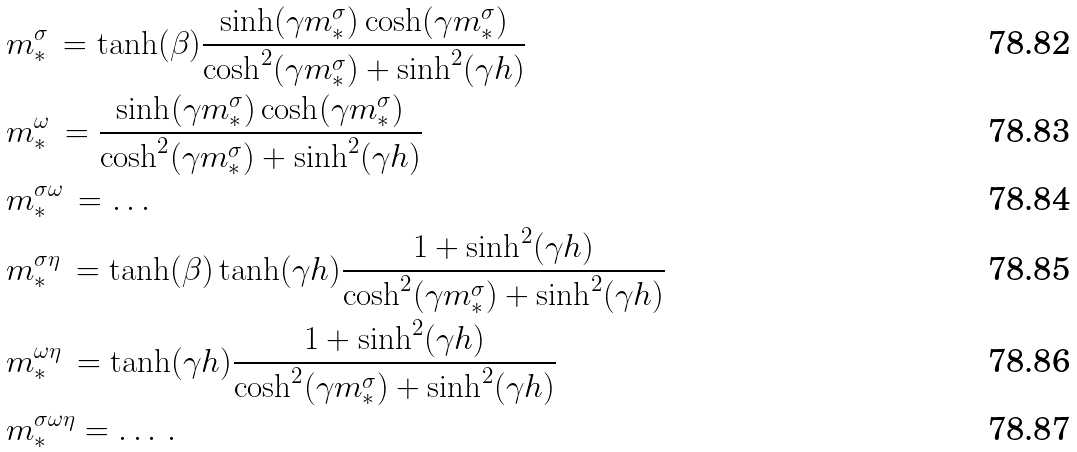<formula> <loc_0><loc_0><loc_500><loc_500>& m ^ { \sigma } _ { * } \, = \tanh ( \beta ) \frac { \sinh ( \gamma m ^ { \sigma } _ { * } ) \cosh ( \gamma m ^ { \sigma } _ { * } ) } { \cosh ^ { 2 } ( \gamma m ^ { \sigma } _ { * } ) + \sinh ^ { 2 } ( \gamma h ) } \\ & m ^ { \omega } _ { * } \, = \frac { \sinh ( \gamma m ^ { \sigma } _ { * } ) \cosh ( \gamma m ^ { \sigma } _ { * } ) } { \cosh ^ { 2 } ( \gamma m ^ { \sigma } _ { * } ) + \sinh ^ { 2 } ( \gamma h ) } \\ & m ^ { \sigma \omega } _ { * } \, = \dots \\ & m ^ { \sigma \eta } _ { * } \, = \tanh ( \beta ) \tanh ( \gamma h ) \frac { 1 + \sinh ^ { 2 } ( \gamma h ) } { \cosh ^ { 2 } ( \gamma m ^ { \sigma } _ { * } ) + \sinh ^ { 2 } ( \gamma h ) } \\ & m ^ { \omega \eta } _ { * } \, = \tanh ( \gamma h ) \frac { 1 + \sinh ^ { 2 } ( \gamma h ) } { \cosh ^ { 2 } ( \gamma m ^ { \sigma } _ { * } ) + \sinh ^ { 2 } ( \gamma h ) } \\ & m ^ { \sigma \omega \eta } _ { * } = \dots \, .</formula> 